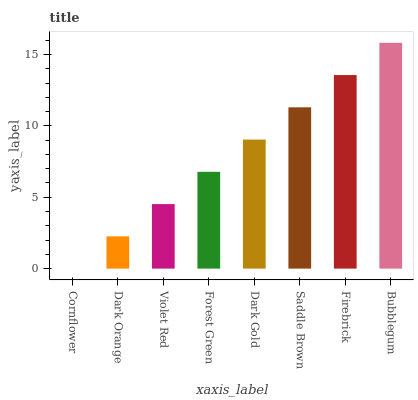Is Cornflower the minimum?
Answer yes or no. Yes. Is Bubblegum the maximum?
Answer yes or no. Yes. Is Dark Orange the minimum?
Answer yes or no. No. Is Dark Orange the maximum?
Answer yes or no. No. Is Dark Orange greater than Cornflower?
Answer yes or no. Yes. Is Cornflower less than Dark Orange?
Answer yes or no. Yes. Is Cornflower greater than Dark Orange?
Answer yes or no. No. Is Dark Orange less than Cornflower?
Answer yes or no. No. Is Dark Gold the high median?
Answer yes or no. Yes. Is Forest Green the low median?
Answer yes or no. Yes. Is Saddle Brown the high median?
Answer yes or no. No. Is Cornflower the low median?
Answer yes or no. No. 